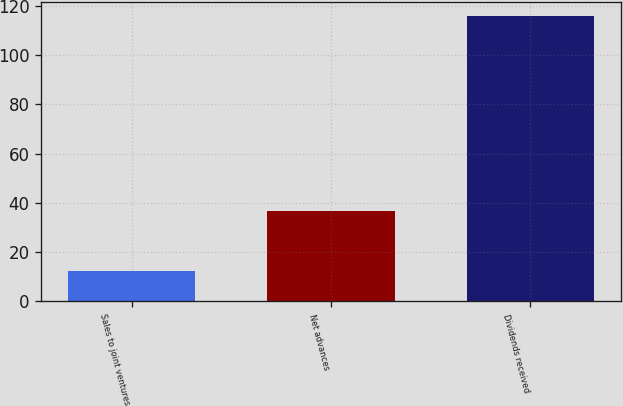<chart> <loc_0><loc_0><loc_500><loc_500><bar_chart><fcel>Sales to joint ventures<fcel>Net advances<fcel>Dividends received<nl><fcel>12.3<fcel>36.7<fcel>115.7<nl></chart> 